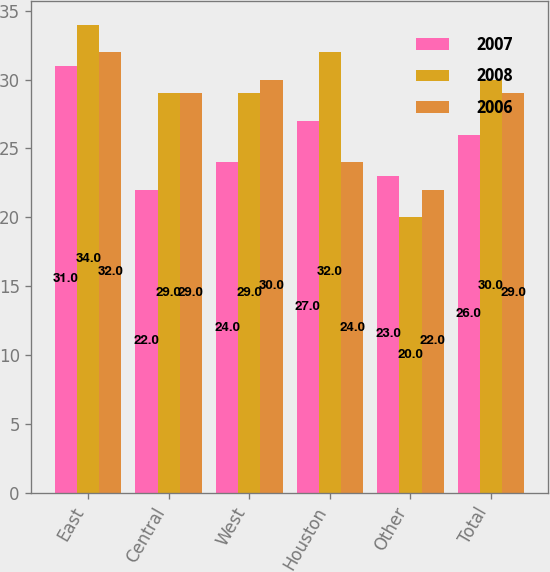Convert chart to OTSL. <chart><loc_0><loc_0><loc_500><loc_500><stacked_bar_chart><ecel><fcel>East<fcel>Central<fcel>West<fcel>Houston<fcel>Other<fcel>Total<nl><fcel>2007<fcel>31<fcel>22<fcel>24<fcel>27<fcel>23<fcel>26<nl><fcel>2008<fcel>34<fcel>29<fcel>29<fcel>32<fcel>20<fcel>30<nl><fcel>2006<fcel>32<fcel>29<fcel>30<fcel>24<fcel>22<fcel>29<nl></chart> 